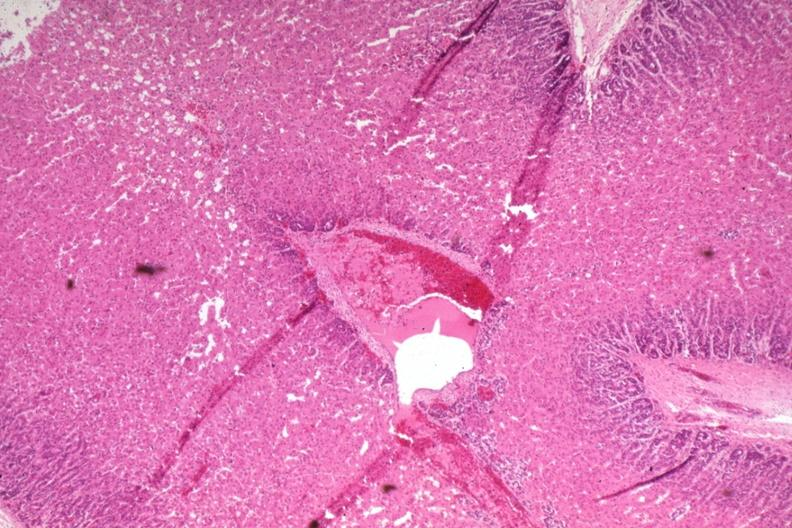does this image show wide fetal zone 2 days old?
Answer the question using a single word or phrase. Yes 